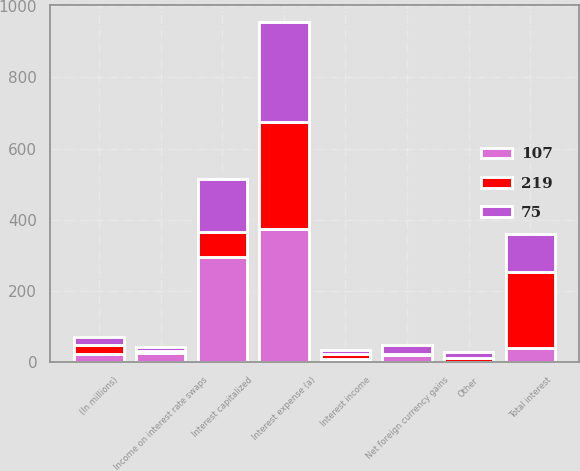Convert chart. <chart><loc_0><loc_0><loc_500><loc_500><stacked_bar_chart><ecel><fcel>(In millions)<fcel>Interest income<fcel>Interest expense (a)<fcel>Income on interest rate swaps<fcel>Interest capitalized<fcel>Total interest<fcel>Net foreign currency gains<fcel>Other<nl><fcel>219<fcel>24<fcel>13<fcel>300<fcel>7<fcel>68<fcel>212<fcel>4<fcel>11<nl><fcel>75<fcel>24<fcel>12<fcel>281<fcel>10<fcel>151<fcel>108<fcel>24<fcel>16<nl><fcel>107<fcel>24<fcel>11<fcel>375<fcel>26<fcel>297<fcel>41<fcel>21<fcel>2<nl></chart> 